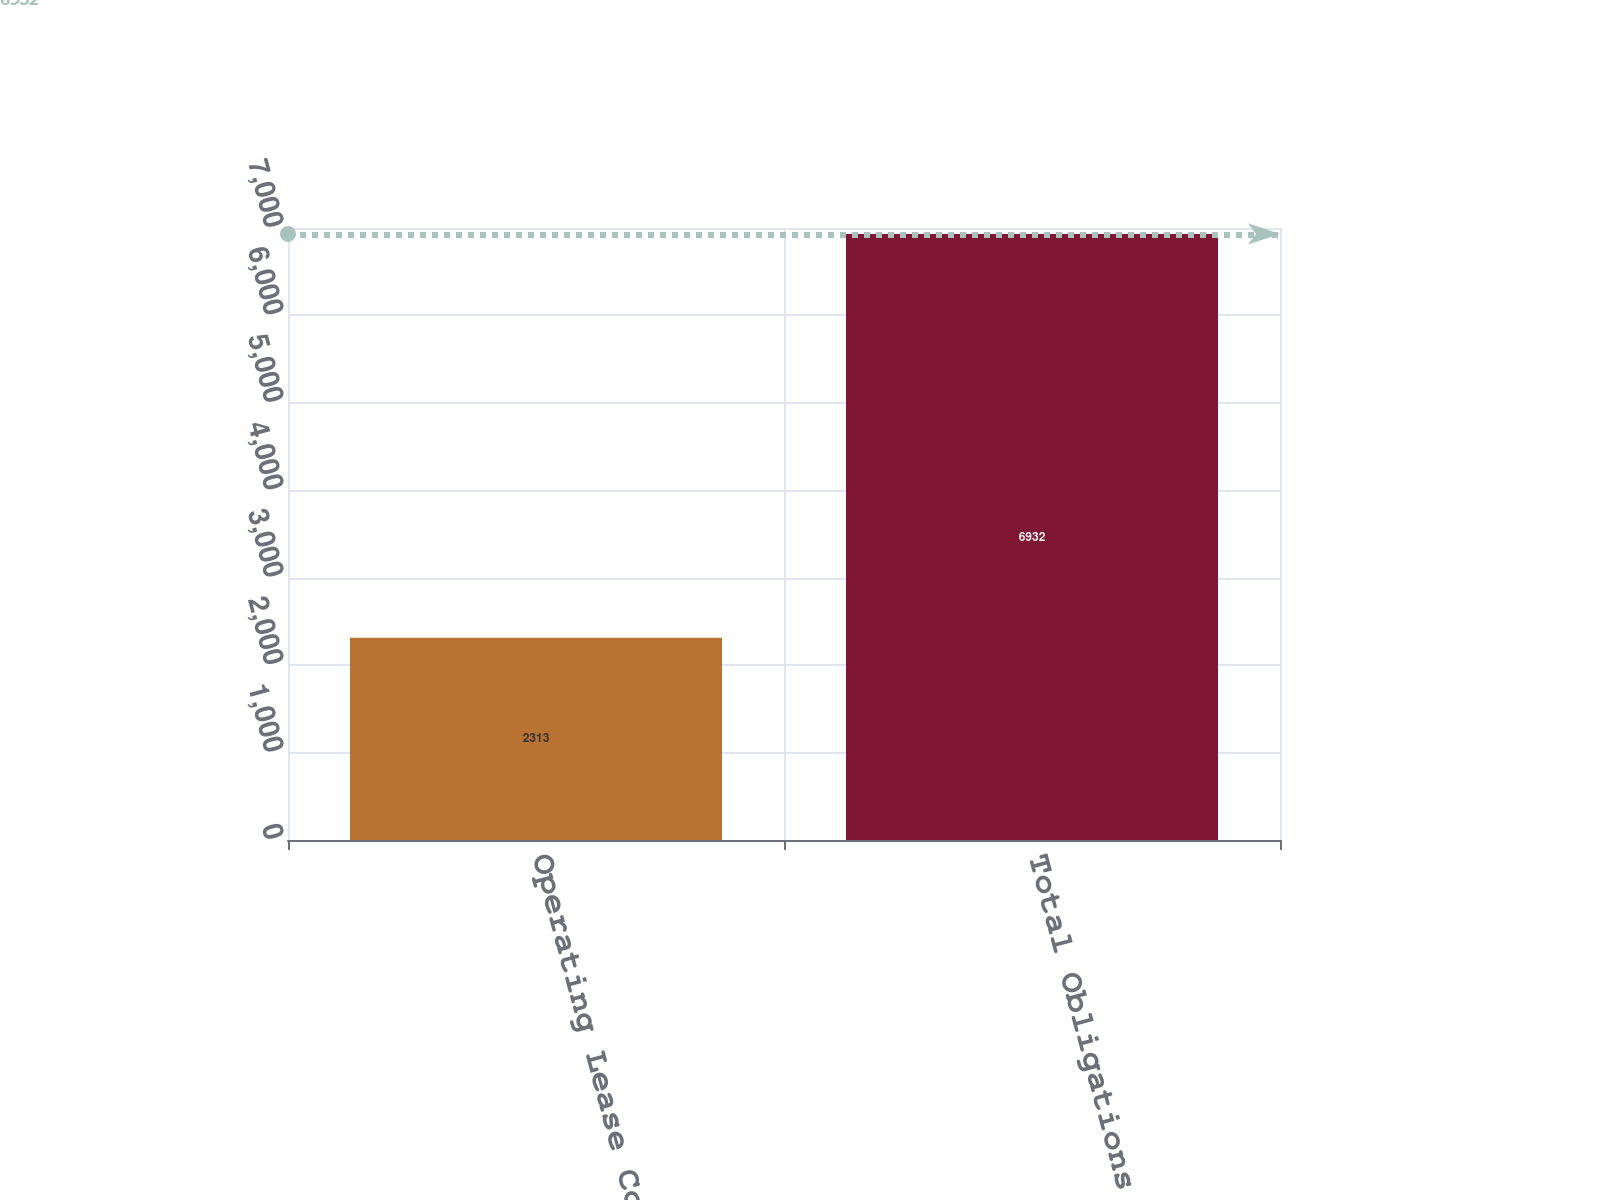Convert chart to OTSL. <chart><loc_0><loc_0><loc_500><loc_500><bar_chart><fcel>Operating Lease Commitments<fcel>Total Obligations<nl><fcel>2313<fcel>6932<nl></chart> 